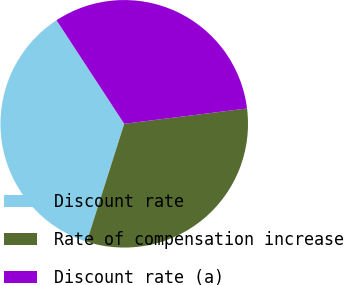<chart> <loc_0><loc_0><loc_500><loc_500><pie_chart><fcel>Discount rate<fcel>Rate of compensation increase<fcel>Discount rate (a)<nl><fcel>35.89%<fcel>31.87%<fcel>32.24%<nl></chart> 